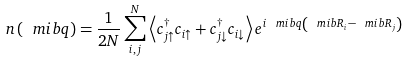<formula> <loc_0><loc_0><loc_500><loc_500>n \left ( \ m i b { q } \right ) = \frac { 1 } { 2 N } \sum _ { i , j } ^ { N } \left \langle c _ { j \uparrow } ^ { \dagger } c _ { i \uparrow } + c _ { j \downarrow } ^ { \dagger } c _ { i \downarrow } \right \rangle e ^ { i \ m i b { q } \left ( \ m i b { R } _ { i } - \ m i b { R } _ { j } \right ) }</formula> 